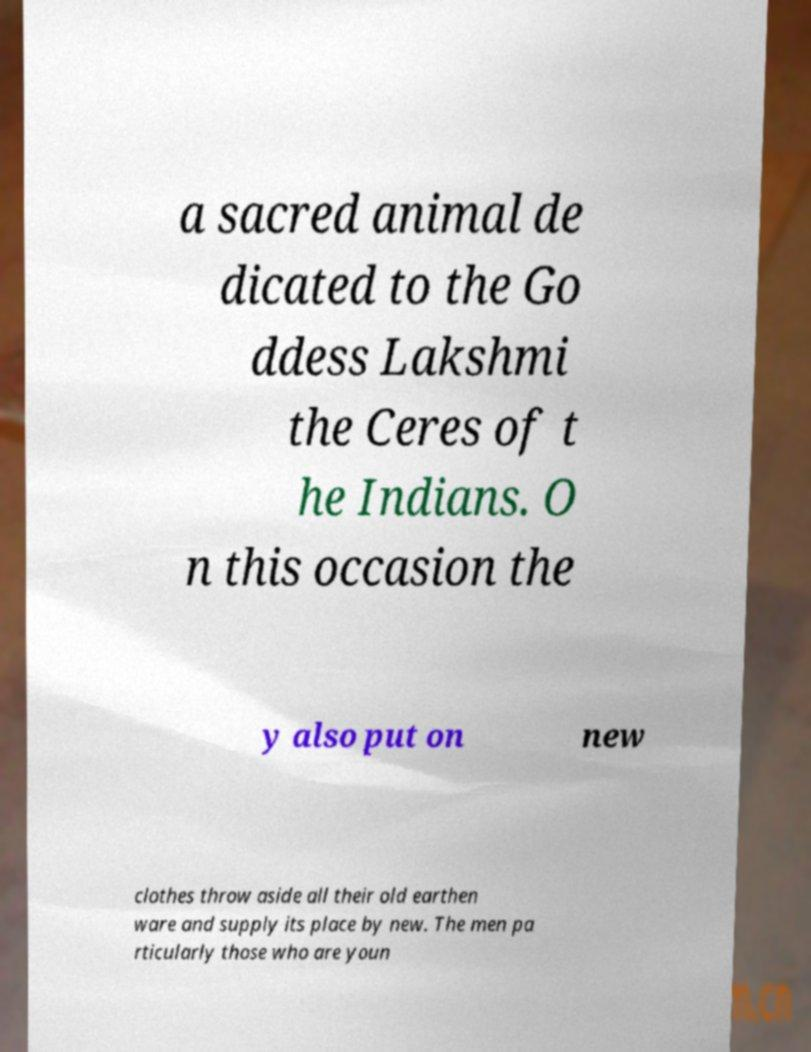What messages or text are displayed in this image? I need them in a readable, typed format. a sacred animal de dicated to the Go ddess Lakshmi the Ceres of t he Indians. O n this occasion the y also put on new clothes throw aside all their old earthen ware and supply its place by new. The men pa rticularly those who are youn 